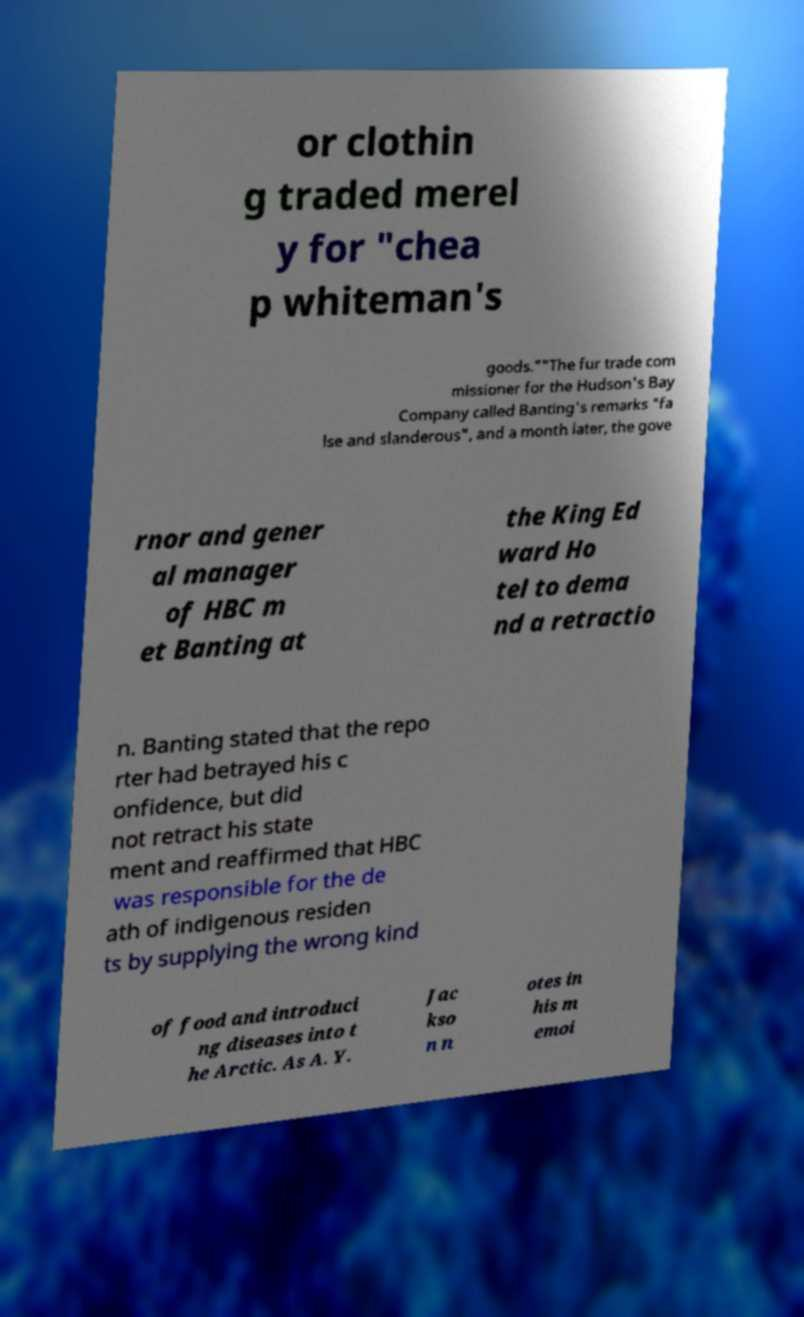I need the written content from this picture converted into text. Can you do that? or clothin g traded merel y for "chea p whiteman's goods.""The fur trade com missioner for the Hudson's Bay Company called Banting's remarks "fa lse and slanderous", and a month later, the gove rnor and gener al manager of HBC m et Banting at the King Ed ward Ho tel to dema nd a retractio n. Banting stated that the repo rter had betrayed his c onfidence, but did not retract his state ment and reaffirmed that HBC was responsible for the de ath of indigenous residen ts by supplying the wrong kind of food and introduci ng diseases into t he Arctic. As A. Y. Jac kso n n otes in his m emoi 